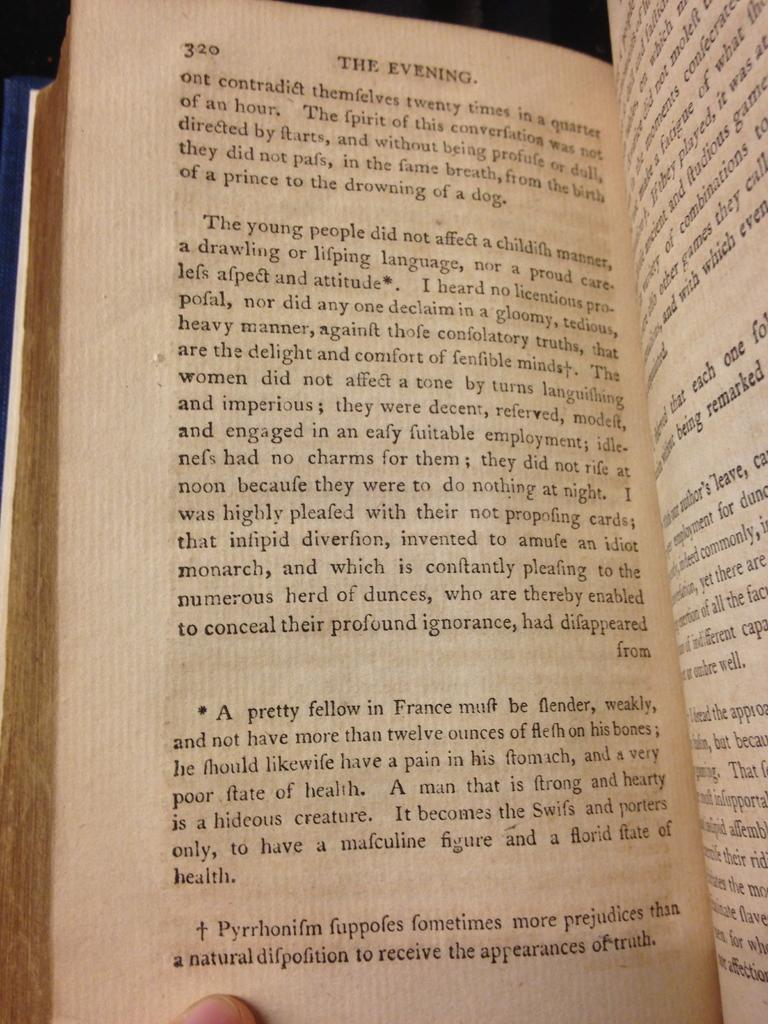Provide a one-sentence caption for the provided image. A book is opened to page 320/321 and the first paragraph on page 320 begins with the words "The young people". 